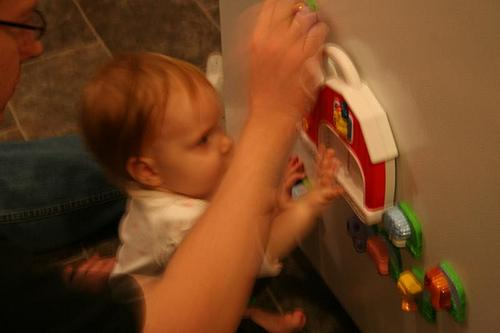What are the two using to play? magnets 